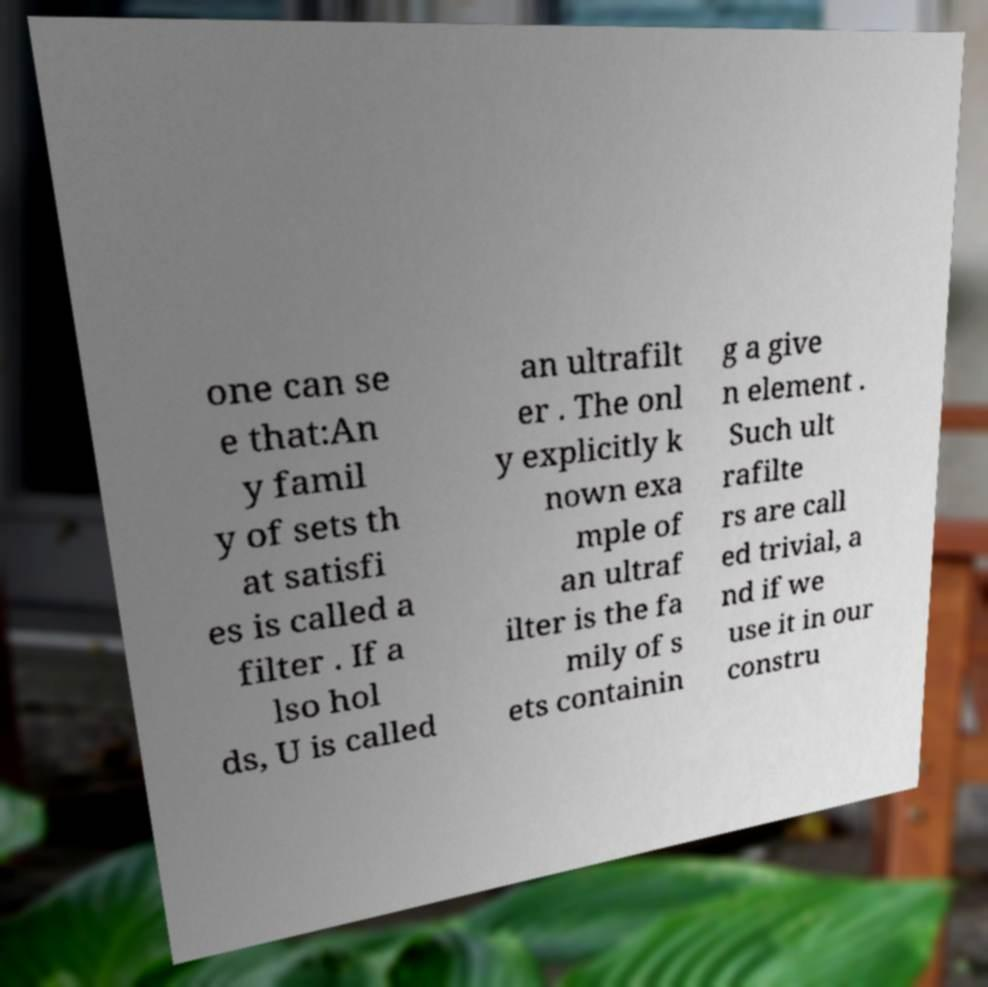Can you read and provide the text displayed in the image?This photo seems to have some interesting text. Can you extract and type it out for me? one can se e that:An y famil y of sets th at satisfi es is called a filter . If a lso hol ds, U is called an ultrafilt er . The onl y explicitly k nown exa mple of an ultraf ilter is the fa mily of s ets containin g a give n element . Such ult rafilte rs are call ed trivial, a nd if we use it in our constru 